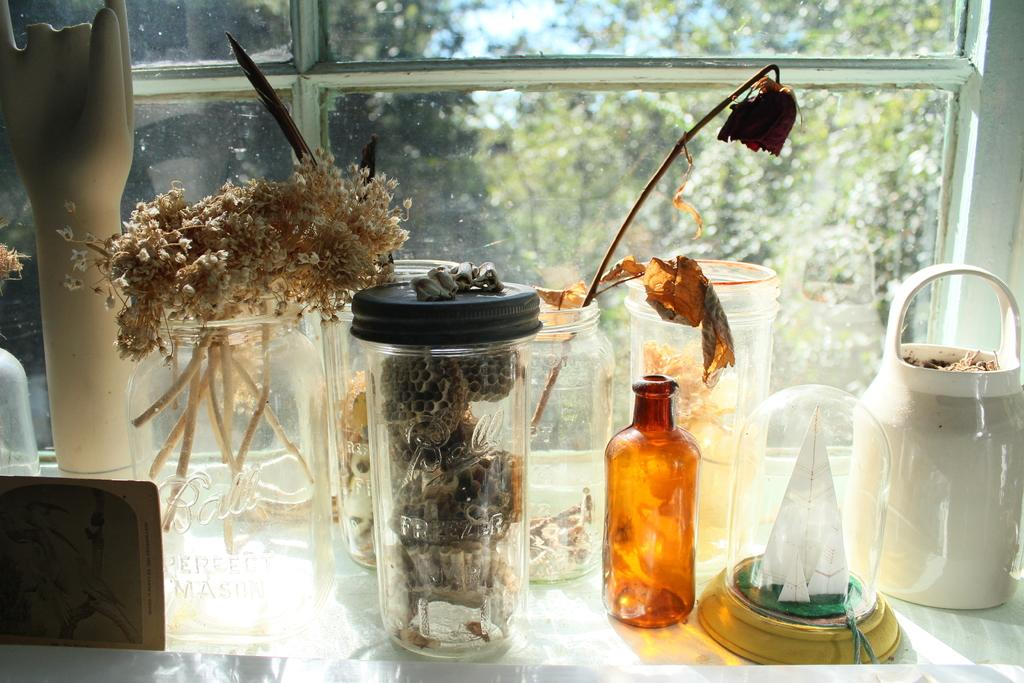What type of containers are present in the image? There are glass jars in the image. What is inside the glass jars? The glass jars contain dried particles. What can be seen through the glass window in the image? There is a glass window in the image, and trees are visible outside the window. How many beds are visible in the image? There are no beds present in the image. 